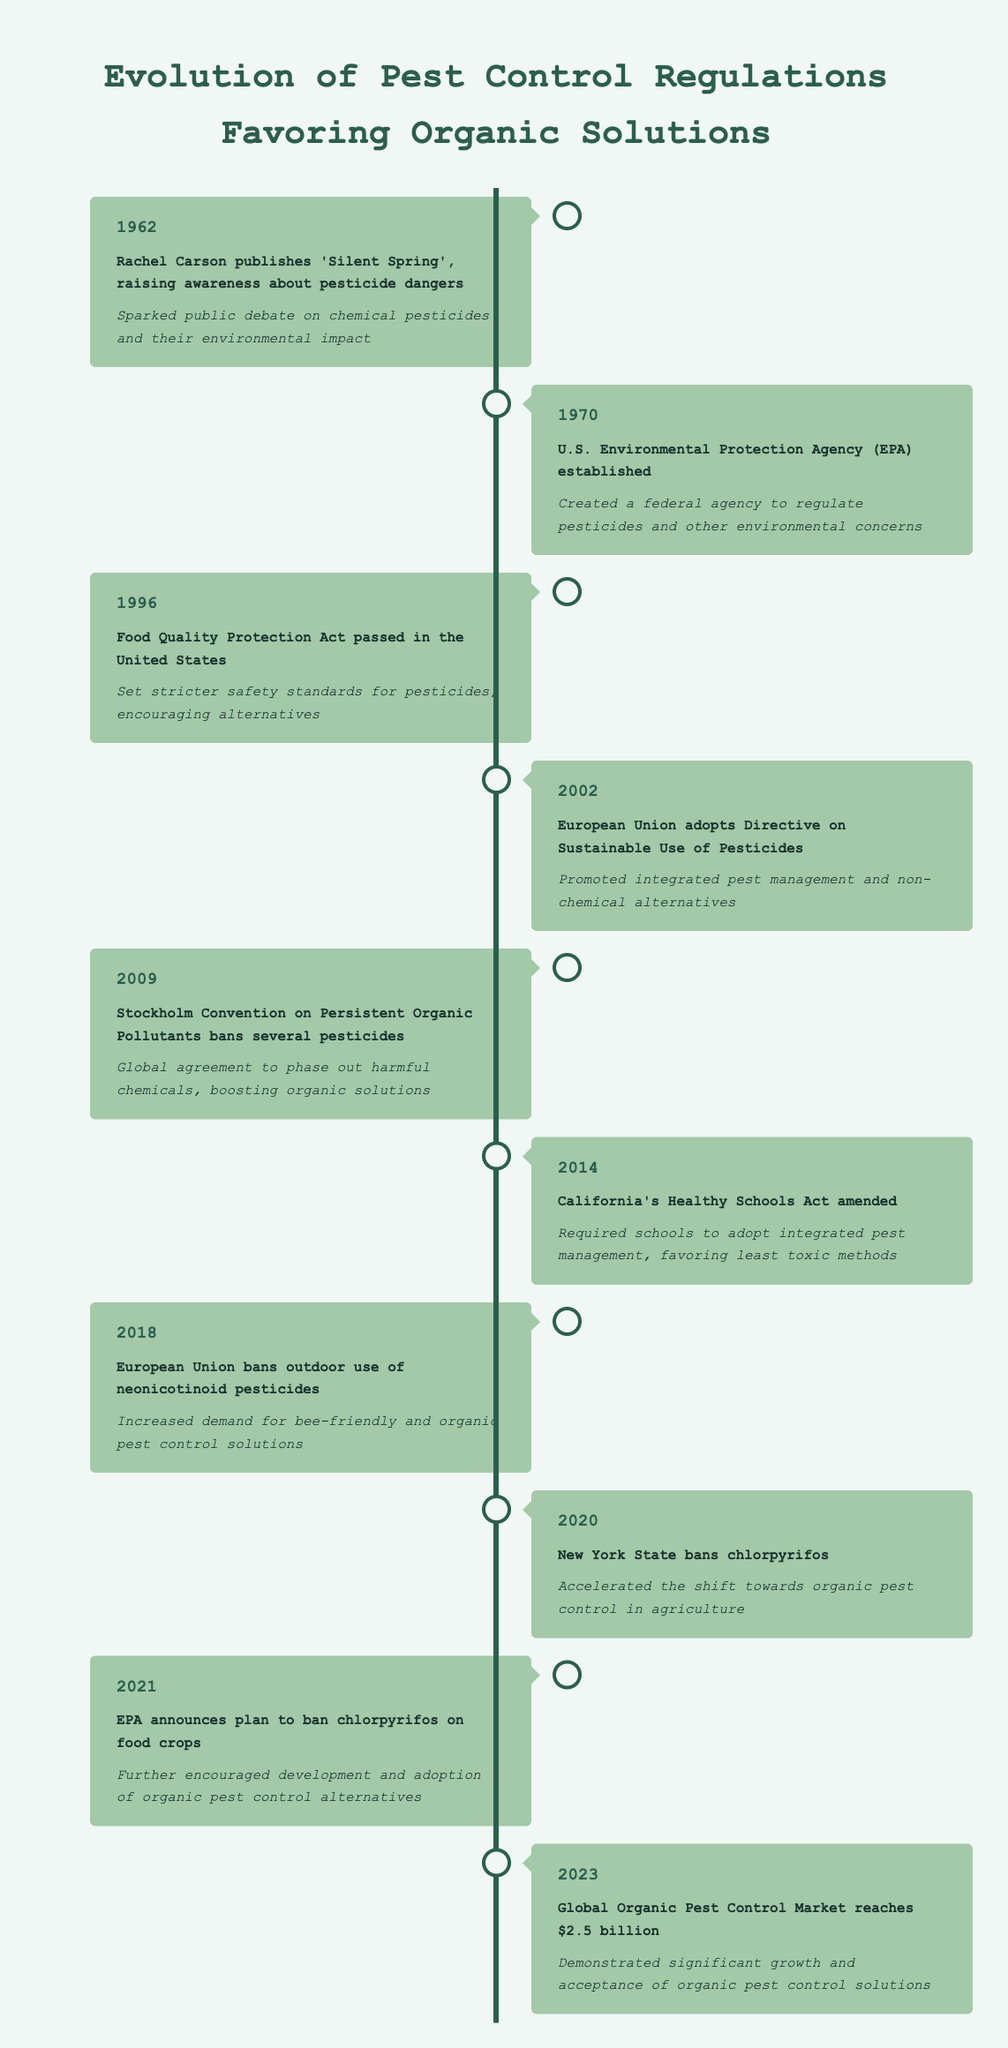What significant publication in 1962 raised awareness about pesticide dangers? The table specifies that Rachel Carson published "Silent Spring" in 1962, which sparked public debate on the dangers of chemical pesticides.
Answer: "Silent Spring" What impact did the establishment of the U.S. Environmental Protection Agency in 1970 have on pesticide regulation? According to the table, the establishment of the EPA created a federal agency responsible for regulating pesticides and broader environmental concerns.
Answer: Created a federal agency to regulate pesticides and other environmental concerns In what year did the European Union ban the outdoor use of neonicotinoid pesticides? The table shows that the European Union implemented this ban in 2018.
Answer: 2018 Which event in 2002 promoted integrated pest management and non-chemical alternatives? The table indicates that in 2002, the European Union adopted the Directive on Sustainable Use of Pesticides, which promoted these practices.
Answer: European Union adopts Directive on Sustainable Use of Pesticides True or False: The Food Quality Protection Act was passed before the EPA was established. By looking at the years provided in the table, the Food Quality Protection Act was passed in 1996, while the EPA was established in 1970, making this statement true.
Answer: False What was the impact of the Stockholm Convention in 2009 on organic pest control solutions? The table states that the Stockholm Convention banned several pesticides, leading to a global effort to phase out harmful chemicals and thus boosting organic solutions.
Answer: Boosting organic solutions How many significant regulations or events favoring organic solutions occurred from 1962 to 2023? By counting the number of entries in the table, there are ten significant events listed that span from 1962 to 2023.
Answer: 10 What is the relationship between the bans introduced in 2020 and 2021 regarding chlorpyrifos? The table indicates that New York State banned chlorpyrifos in 2020, and in 2021, the EPA also announced a plan to ban chlorpyrifos on food crops, indicating a coordinated effort to reduce reliance on this chemical.
Answer: Coordinated effort to reduce reliance on chlorpyrifos Calculate the time span between the publication of "Silent Spring" and the achievement of the $2.5 billion market in 2023. To find the time span, subtract the year of publication (1962) from the market achievement year (2023): 2023 - 1962 = 61 years.
Answer: 61 years 